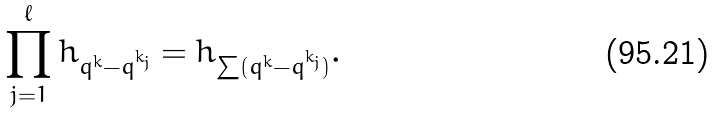<formula> <loc_0><loc_0><loc_500><loc_500>\prod _ { j = 1 } ^ { \ell } h _ { q ^ { k } - q ^ { k _ { j } } } = h _ { \sum ( q ^ { k } - q ^ { k _ { j } } ) } .</formula> 